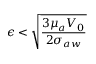<formula> <loc_0><loc_0><loc_500><loc_500>{ \epsilon } < \sqrt { \frac { 3 { \mu } _ { a } V _ { 0 } } { 2 { \sigma } _ { a w } } }</formula> 